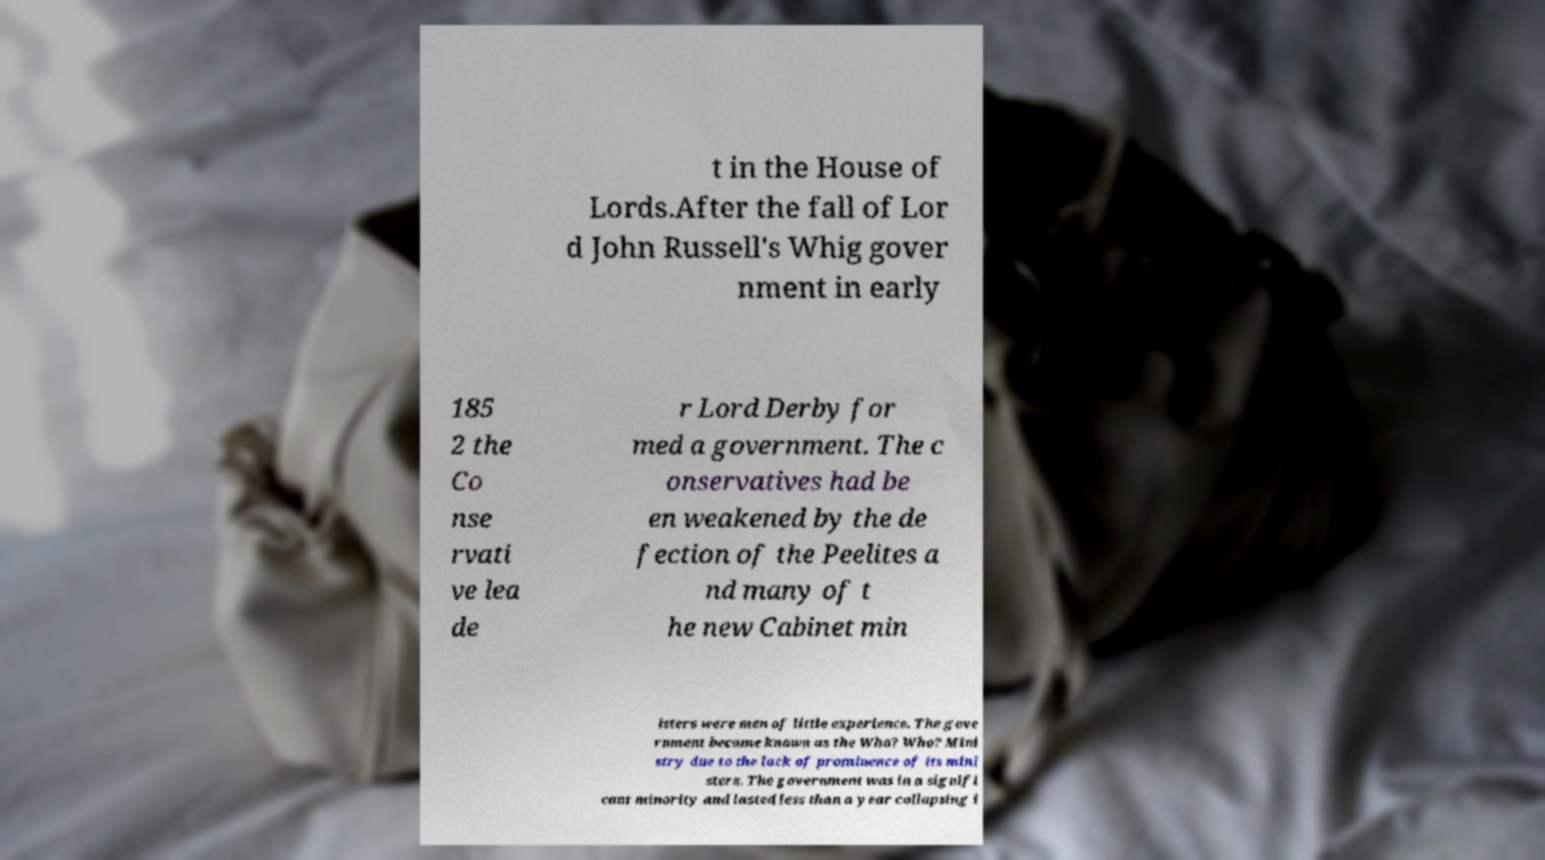Could you extract and type out the text from this image? t in the House of Lords.After the fall of Lor d John Russell's Whig gover nment in early 185 2 the Co nse rvati ve lea de r Lord Derby for med a government. The c onservatives had be en weakened by the de fection of the Peelites a nd many of t he new Cabinet min isters were men of little experience. The gove rnment became known as the Who? Who? Mini stry due to the lack of prominence of its mini sters. The government was in a signifi cant minority and lasted less than a year collapsing i 